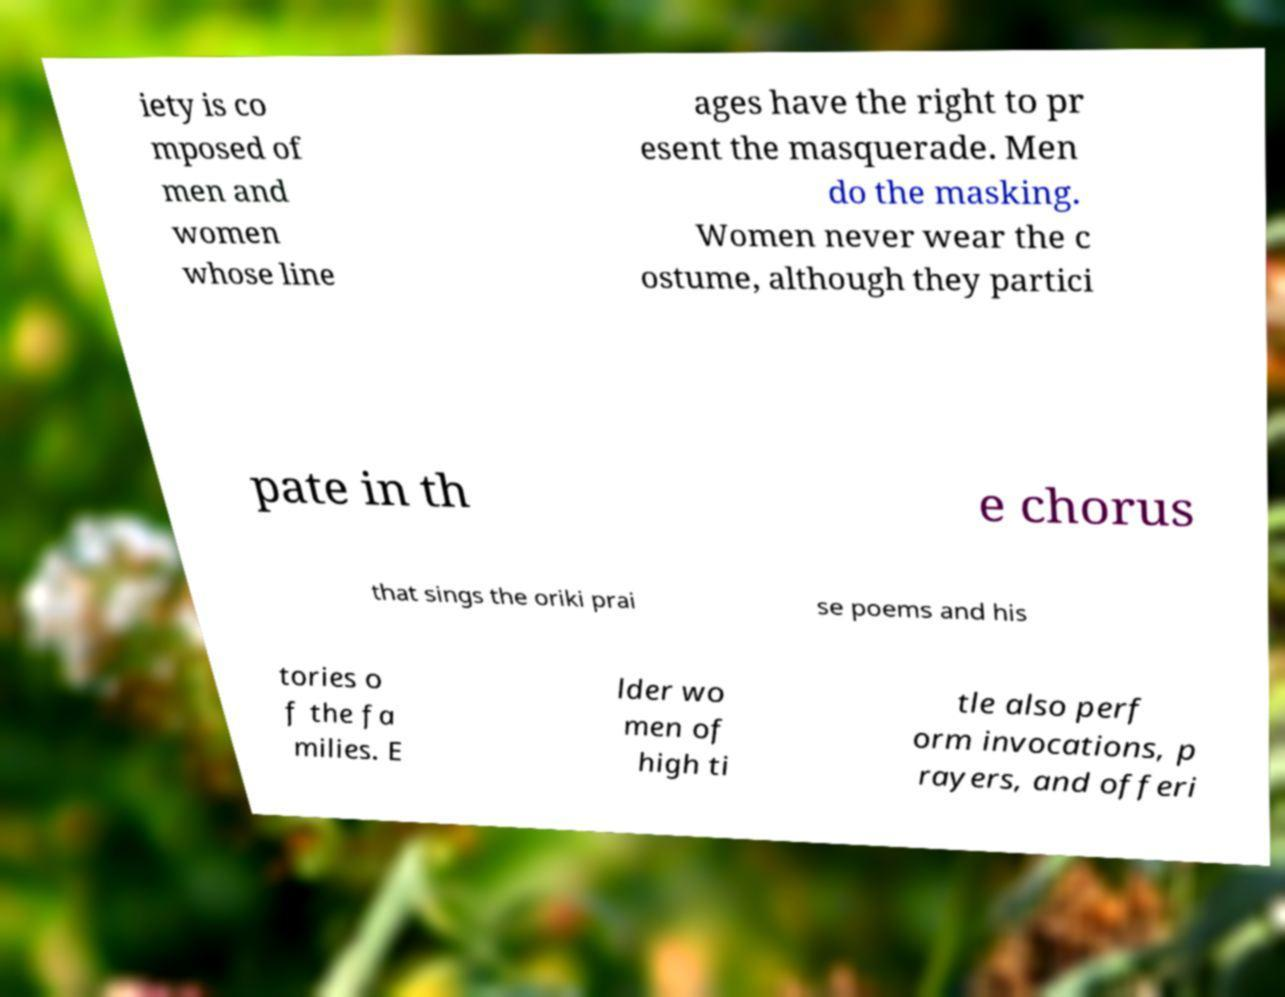Could you assist in decoding the text presented in this image and type it out clearly? iety is co mposed of men and women whose line ages have the right to pr esent the masquerade. Men do the masking. Women never wear the c ostume, although they partici pate in th e chorus that sings the oriki prai se poems and his tories o f the fa milies. E lder wo men of high ti tle also perf orm invocations, p rayers, and offeri 